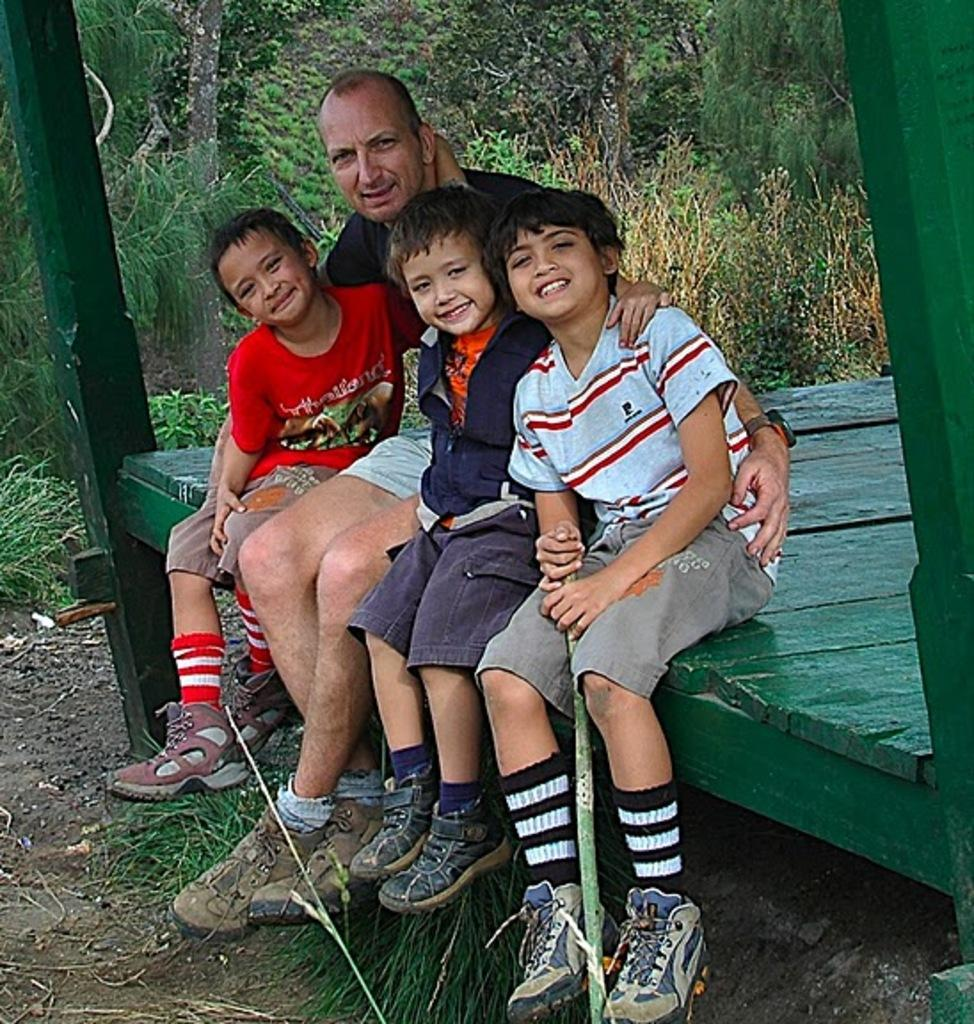Where was the picture taken? The picture was clicked outside. How many kids are visible on the right side of the image? There are three kids on the right side of the image. Who is with the kids in the image? There is a person sitting with the kids. What color is the object the kids and person are sitting on? The green color object they are sitting on is visible. What type of vegetation can be seen in the background of the image? There is grass and plants in the background of the image. Can you tell me what the women are arguing about in the image? There are no women present in the image, nor is there any argument taking place. What type of bird can be seen perched on the person's shoulder in the image? There is no bird, specifically a wren, present in the image. 